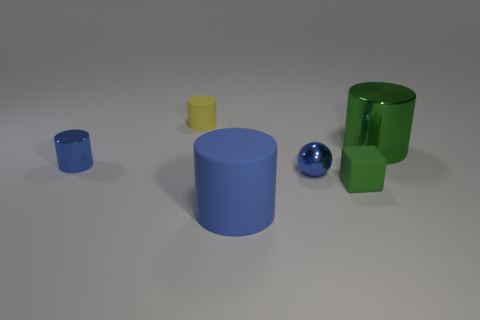How many things are both to the right of the small matte cylinder and behind the blue rubber thing?
Provide a short and direct response. 3. What number of other objects are there of the same shape as the big blue thing?
Give a very brief answer. 3. Is the number of matte things that are to the left of the tiny yellow cylinder greater than the number of green matte things?
Offer a terse response. No. What color is the small matte object to the right of the yellow matte thing?
Provide a succinct answer. Green. The other thing that is the same color as the big metal object is what size?
Keep it short and to the point. Small. What number of metallic objects are green balls or cubes?
Provide a succinct answer. 0. There is a big thing in front of the big cylinder behind the tiny matte cube; are there any large rubber objects that are behind it?
Give a very brief answer. No. There is a large blue rubber cylinder; how many tiny yellow cylinders are to the left of it?
Provide a succinct answer. 1. There is a small object that is the same color as the tiny metal ball; what is its material?
Keep it short and to the point. Metal. How many tiny things are either balls or green cylinders?
Keep it short and to the point. 1. 